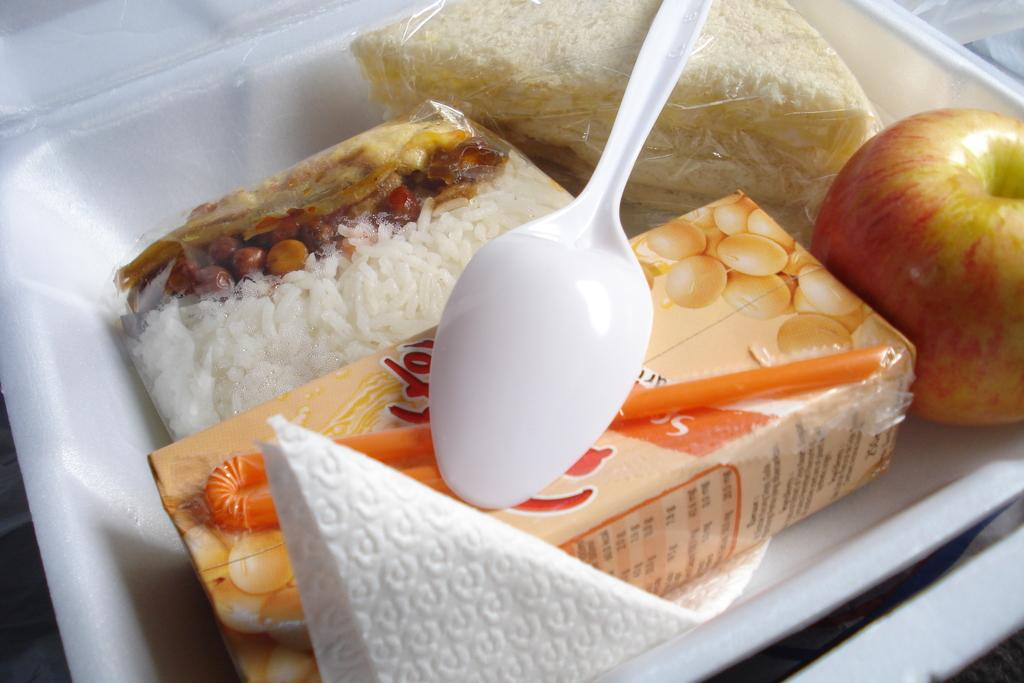What types of food items can be seen in the image? There are food items in the image, including an apple. What beverage is present in the image? There is juice in the image. What utensil is visible in the image? There is a plastic spoon in the image. What is used for cleaning or wiping in the image? There is a tissue in the image. How are the food items, juice, and utensils arranged in the image? The items are arranged in a thermocol box. What type of house is visible in the image? There is no house present in the image; it features food items, juice, a plastic spoon, a tissue, and a thermocol box. What is the mass of the jewel in the image? There is no jewel present in the image, so its mass cannot be determined. 